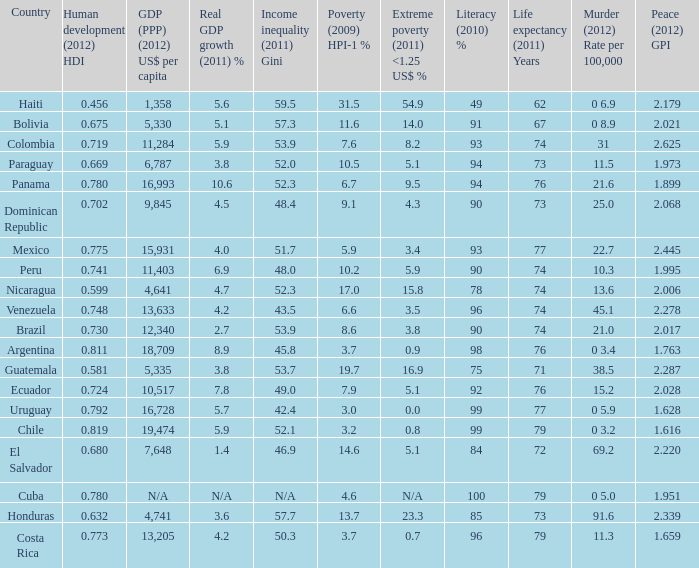What is the total poverty (2009) HPI-1 % when the extreme poverty (2011) <1.25 US$ % of 16.9, and the human development (2012) HDI is less than 0.581? None. 